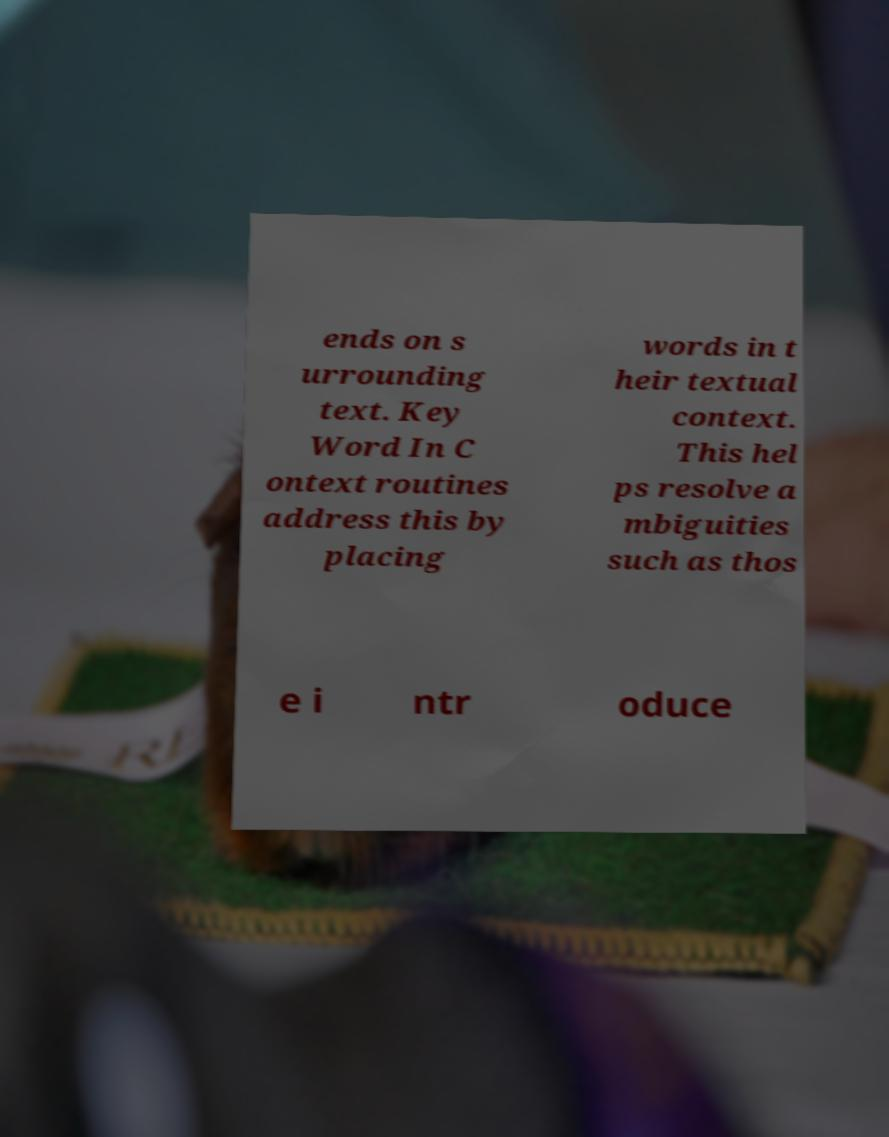Please identify and transcribe the text found in this image. ends on s urrounding text. Key Word In C ontext routines address this by placing words in t heir textual context. This hel ps resolve a mbiguities such as thos e i ntr oduce 